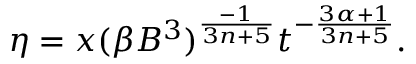Convert formula to latex. <formula><loc_0><loc_0><loc_500><loc_500>\eta = x ( \beta B ^ { 3 } ) ^ { \frac { - 1 } { 3 n + 5 } } t ^ { - \frac { 3 \alpha + 1 } { 3 n + 5 } } .</formula> 